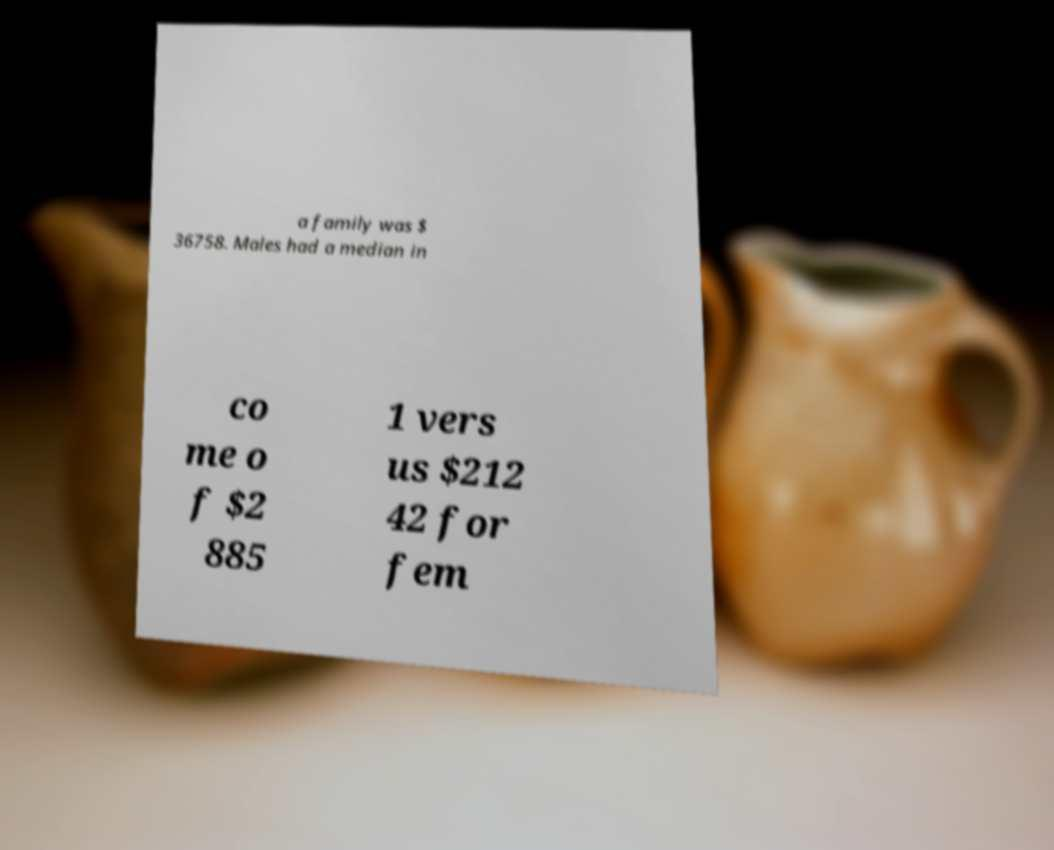Can you accurately transcribe the text from the provided image for me? a family was $ 36758. Males had a median in co me o f $2 885 1 vers us $212 42 for fem 